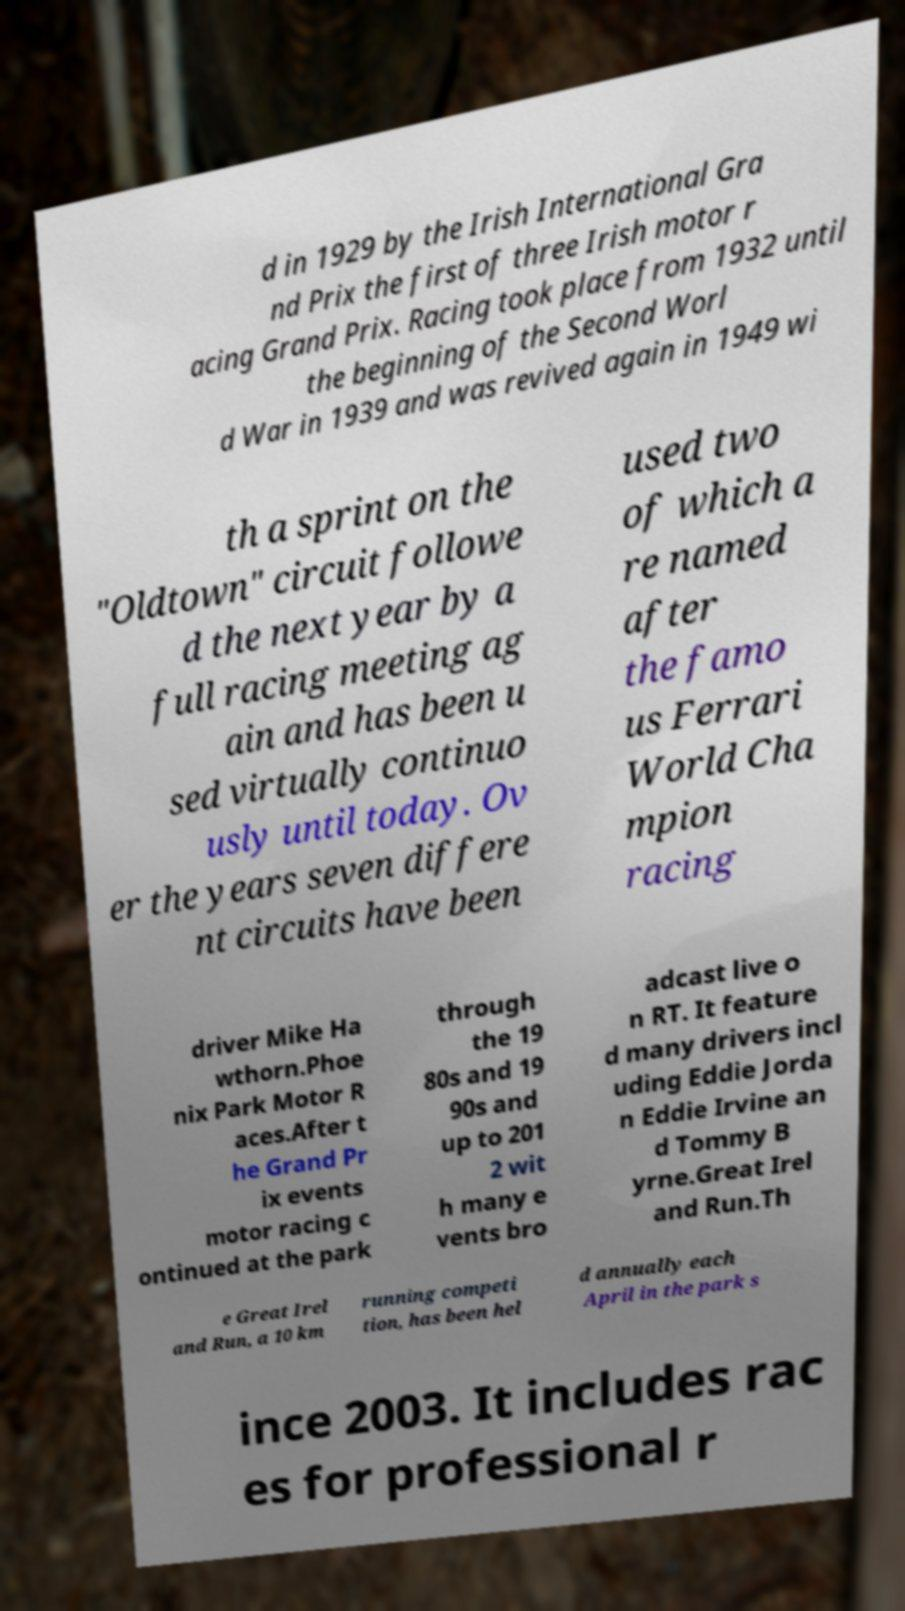What messages or text are displayed in this image? I need them in a readable, typed format. d in 1929 by the Irish International Gra nd Prix the first of three Irish motor r acing Grand Prix. Racing took place from 1932 until the beginning of the Second Worl d War in 1939 and was revived again in 1949 wi th a sprint on the "Oldtown" circuit followe d the next year by a full racing meeting ag ain and has been u sed virtually continuo usly until today. Ov er the years seven differe nt circuits have been used two of which a re named after the famo us Ferrari World Cha mpion racing driver Mike Ha wthorn.Phoe nix Park Motor R aces.After t he Grand Pr ix events motor racing c ontinued at the park through the 19 80s and 19 90s and up to 201 2 wit h many e vents bro adcast live o n RT. It feature d many drivers incl uding Eddie Jorda n Eddie Irvine an d Tommy B yrne.Great Irel and Run.Th e Great Irel and Run, a 10 km running competi tion, has been hel d annually each April in the park s ince 2003. It includes rac es for professional r 